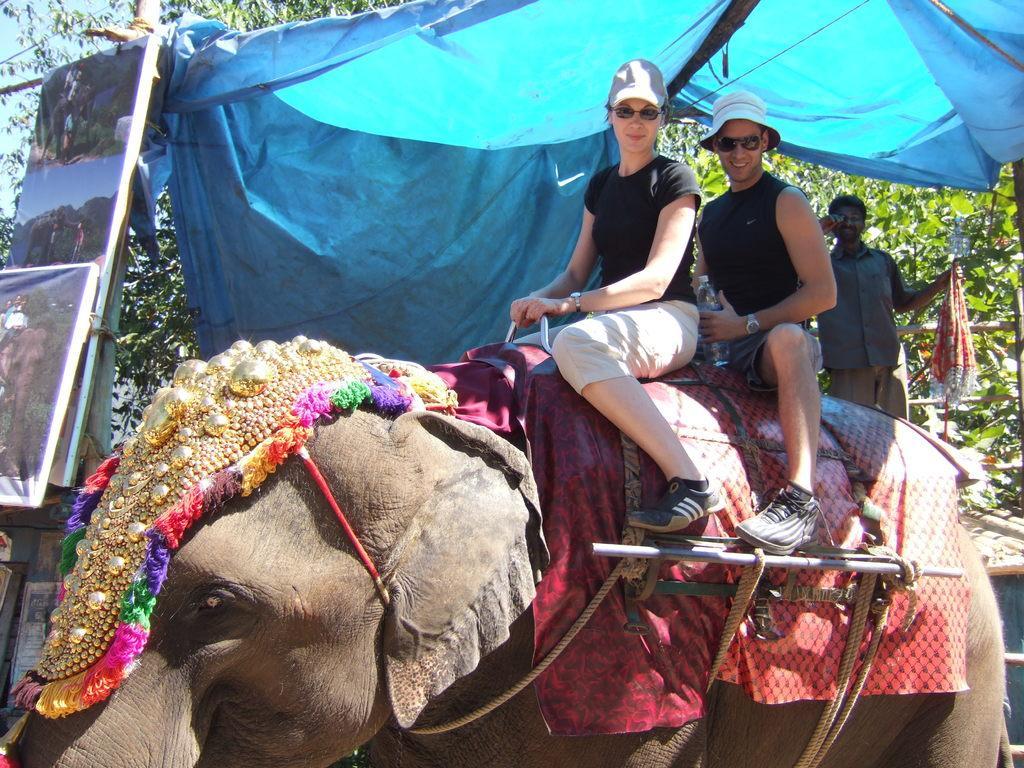In one or two sentences, can you explain what this image depicts? These two persons are sitting on the elephant and wear caps,glasses. On the background we can see person holding cloth,trees,tent ,boards. 